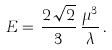<formula> <loc_0><loc_0><loc_500><loc_500>E = \, \frac { 2 \, \sqrt { 2 } } { 3 } \, \frac { { \mu } ^ { 3 } } { \lambda } \, .</formula> 